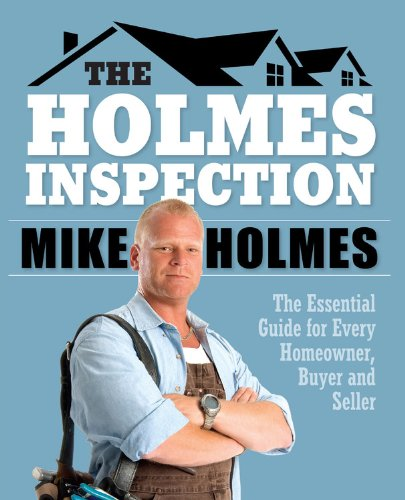How could the information in the book be valuable for first-time home buyers? For first-time home buyers, this book acts as a critical guide to navigating the typically complex and overwhelming process of buying a home. It educates readers on what to inspect and consider before making a purchase, potentially saving them from costly mistakes and unforeseen repairs. 